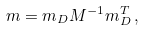<formula> <loc_0><loc_0><loc_500><loc_500>m = m _ { D } M ^ { - 1 } m ^ { T } _ { D } \, ,</formula> 